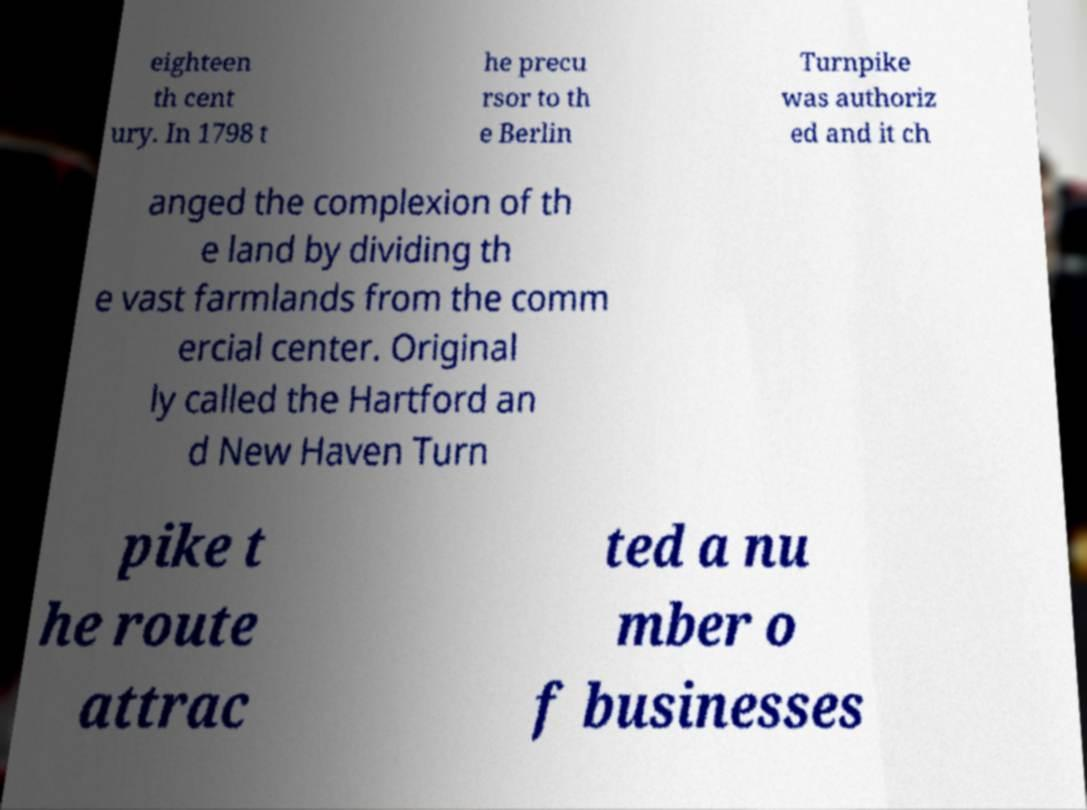Could you assist in decoding the text presented in this image and type it out clearly? eighteen th cent ury. In 1798 t he precu rsor to th e Berlin Turnpike was authoriz ed and it ch anged the complexion of th e land by dividing th e vast farmlands from the comm ercial center. Original ly called the Hartford an d New Haven Turn pike t he route attrac ted a nu mber o f businesses 